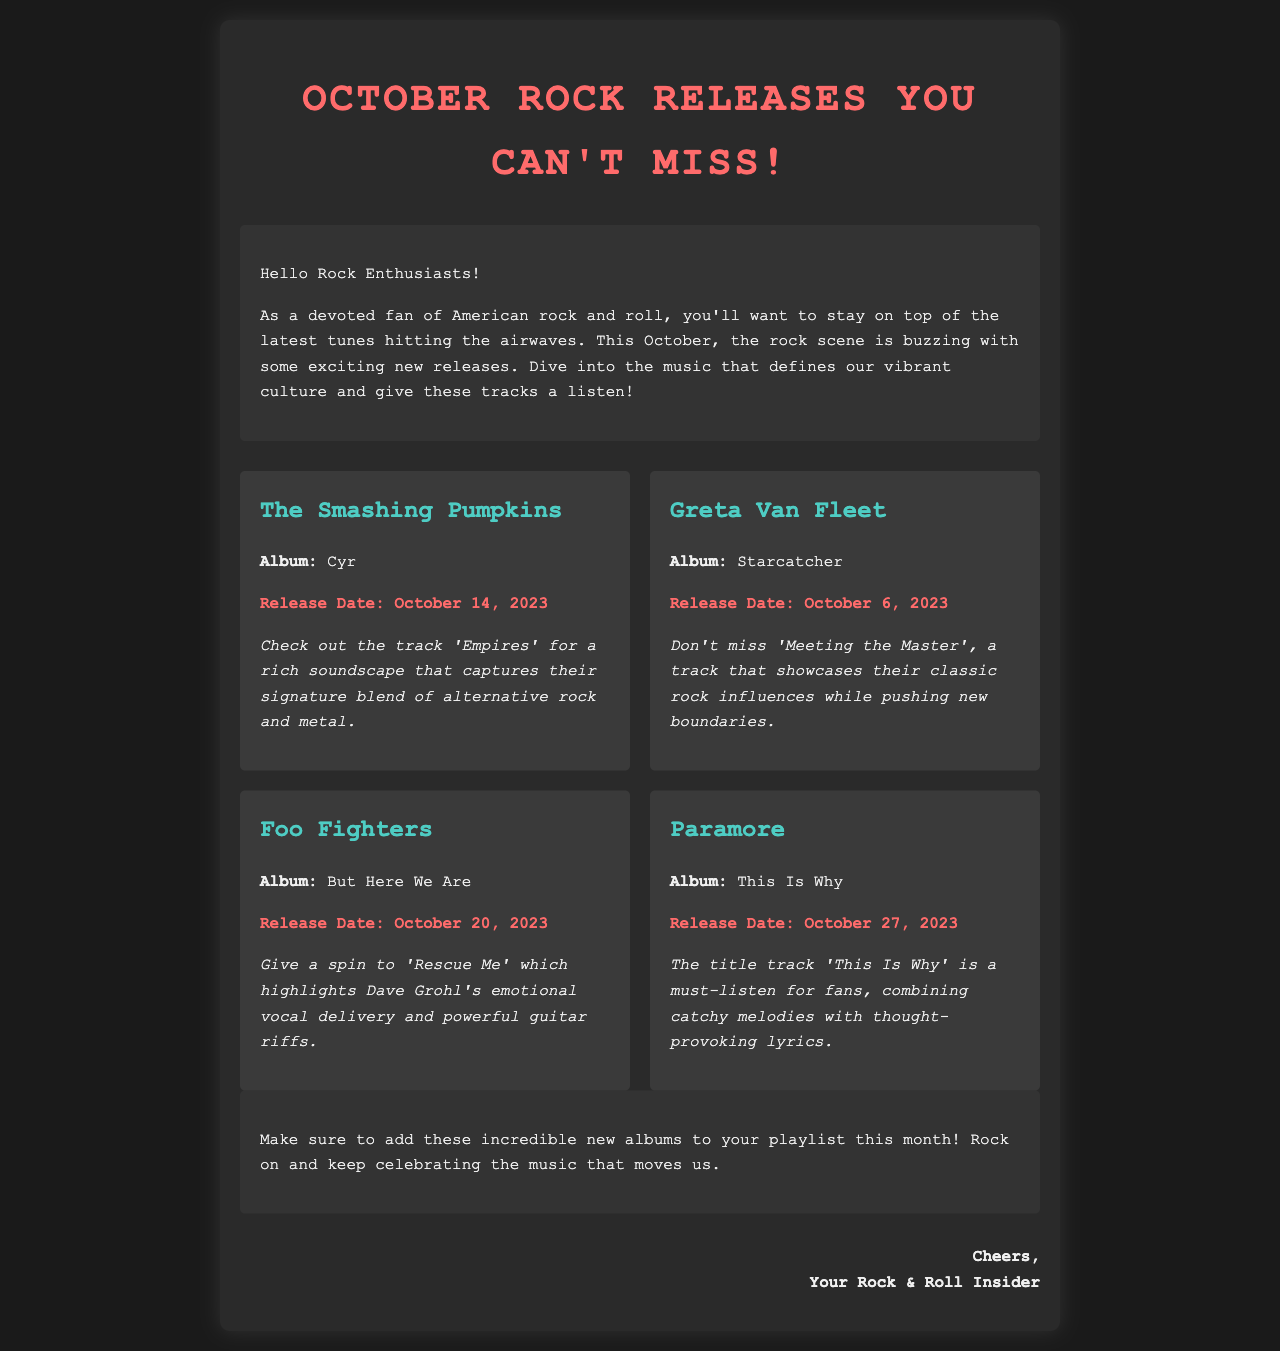What is the title of the email? The title of the email is stated at the beginning and informs the readers about the topic of the email.
Answer: October Rock Releases You Can't Miss! Who is the artist for the album "Cyr"? The document lists the artist associated with the album title "Cyr", indicating who created the music.
Answer: The Smashing Pumpkins When is "Starcatcher" being released? The release date for the album "Starcatcher" is provided in the document, which informs readers about when to expect the album.
Answer: October 6, 2023 What track is suggested to listen to from the album "But Here We Are"? The document suggests a specific track to listen to, helping readers decide what to try first from the album.
Answer: Rescue Me Which album by Paramore is mentioned in the email? The email highlights the name of Paramore's new album, indicating what they are currently promoting.
Answer: This Is Why What type of music is described in The Smashing Pumpkins' suggestion? The suggestion for The Smashing Pumpkins refers to the style or genre of music that their track represents.
Answer: Alternative rock and metal How does the email describe the track 'Meeting the Master'? The document includes an evaluative description of this track that provides insight into its sound and influences.
Answer: Showcases their classic rock influences while pushing new boundaries Who is the email addressed to? The introductory greeting implies the target audience of the email, revealing who the content is intended for.
Answer: Rock Enthusiasts 